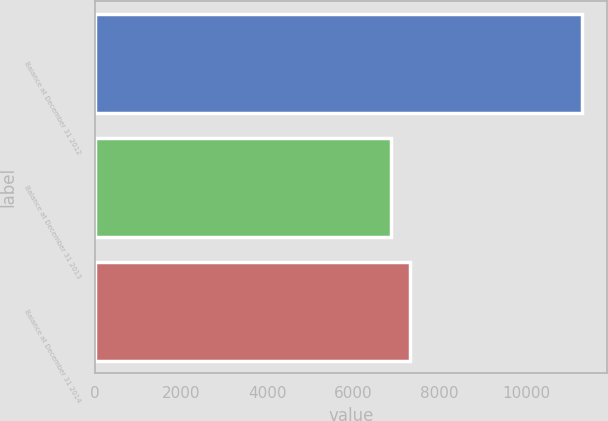<chart> <loc_0><loc_0><loc_500><loc_500><bar_chart><fcel>Balance at December 31 2012<fcel>Balance at December 31 2013<fcel>Balance at December 31 2014<nl><fcel>11311<fcel>6876<fcel>7319.5<nl></chart> 